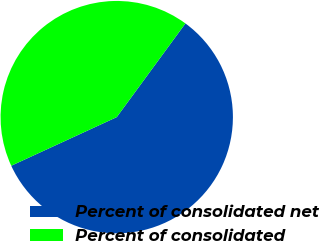<chart> <loc_0><loc_0><loc_500><loc_500><pie_chart><fcel>Percent of consolidated net<fcel>Percent of consolidated<nl><fcel>58.06%<fcel>41.94%<nl></chart> 